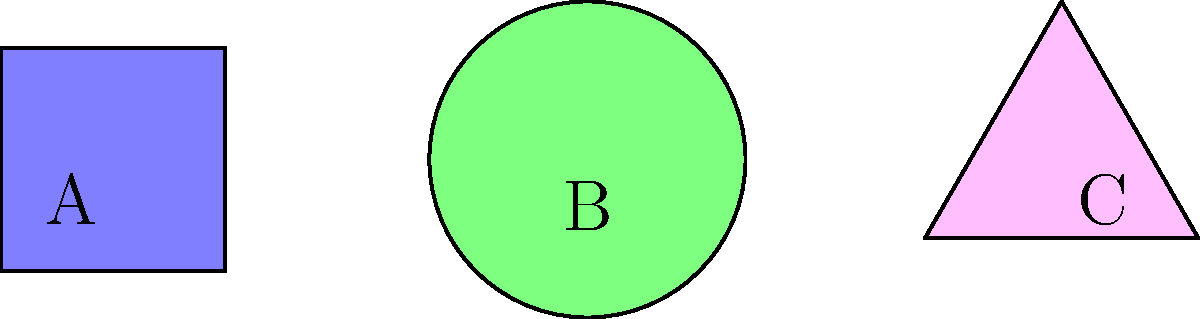Look at the picture. Which shape is B? Let's look at the shapes one by one:

1. Shape A (on the left): This shape has four equal sides and four corners. It is blue. This is a square.

2. Shape B (in the middle): This shape is round and green. It has no corners. This is a circle.

3. Shape C (on the right): This shape has three sides and three corners. It is pink. This is a triangle.

The question asks about shape B, which is in the middle. We can see that it is round and has no corners. Therefore, shape B is a circle.
Answer: Circle 